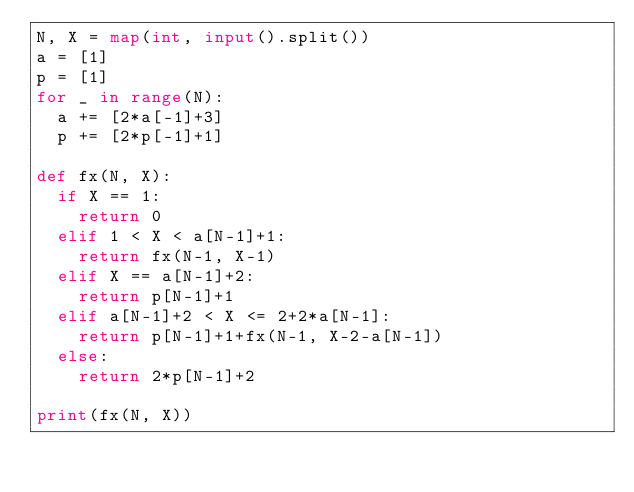<code> <loc_0><loc_0><loc_500><loc_500><_Python_>N, X = map(int, input().split())
a = [1]
p = [1]
for _ in range(N):
  a += [2*a[-1]+3]
  p += [2*p[-1]+1]

def fx(N, X):
  if X == 1:
    return 0
  elif 1 < X < a[N-1]+1:
    return fx(N-1, X-1)
  elif X == a[N-1]+2:
    return p[N-1]+1
  elif a[N-1]+2 < X <= 2+2*a[N-1]:
    return p[N-1]+1+fx(N-1, X-2-a[N-1])
  else:
    return 2*p[N-1]+2

print(fx(N, X))
</code> 